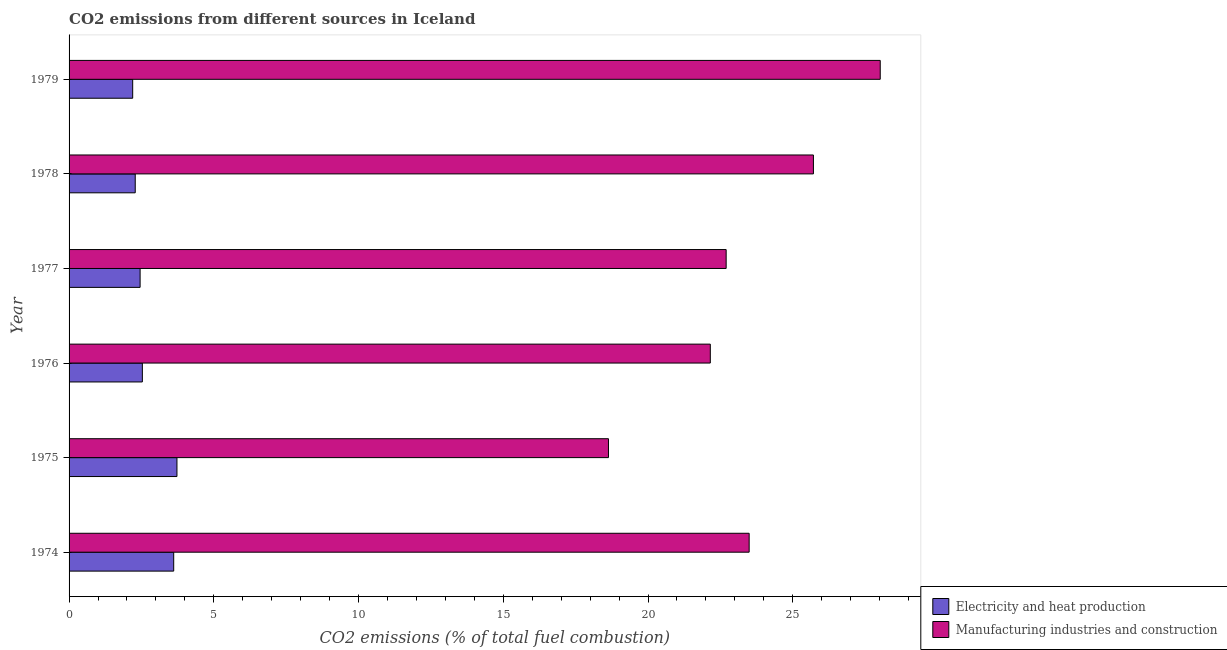How many different coloured bars are there?
Your answer should be compact. 2. How many groups of bars are there?
Make the answer very short. 6. Are the number of bars on each tick of the Y-axis equal?
Your answer should be very brief. Yes. How many bars are there on the 4th tick from the top?
Provide a short and direct response. 2. How many bars are there on the 5th tick from the bottom?
Give a very brief answer. 2. What is the label of the 2nd group of bars from the top?
Provide a succinct answer. 1978. What is the co2 emissions due to electricity and heat production in 1975?
Keep it short and to the point. 3.73. Across all years, what is the maximum co2 emissions due to electricity and heat production?
Provide a short and direct response. 3.73. Across all years, what is the minimum co2 emissions due to manufacturing industries?
Provide a short and direct response. 18.63. In which year was the co2 emissions due to electricity and heat production maximum?
Offer a very short reply. 1975. In which year was the co2 emissions due to manufacturing industries minimum?
Your response must be concise. 1975. What is the total co2 emissions due to manufacturing industries in the graph?
Offer a very short reply. 140.72. What is the difference between the co2 emissions due to manufacturing industries in 1974 and that in 1977?
Ensure brevity in your answer.  0.8. What is the difference between the co2 emissions due to electricity and heat production in 1975 and the co2 emissions due to manufacturing industries in 1974?
Keep it short and to the point. -19.77. What is the average co2 emissions due to manufacturing industries per year?
Your answer should be very brief. 23.45. In the year 1975, what is the difference between the co2 emissions due to electricity and heat production and co2 emissions due to manufacturing industries?
Provide a short and direct response. -14.91. What is the ratio of the co2 emissions due to electricity and heat production in 1976 to that in 1977?
Keep it short and to the point. 1.03. Is the difference between the co2 emissions due to electricity and heat production in 1976 and 1978 greater than the difference between the co2 emissions due to manufacturing industries in 1976 and 1978?
Ensure brevity in your answer.  Yes. What is the difference between the highest and the second highest co2 emissions due to manufacturing industries?
Give a very brief answer. 2.31. What is the difference between the highest and the lowest co2 emissions due to electricity and heat production?
Ensure brevity in your answer.  1.53. In how many years, is the co2 emissions due to electricity and heat production greater than the average co2 emissions due to electricity and heat production taken over all years?
Provide a succinct answer. 2. Is the sum of the co2 emissions due to electricity and heat production in 1974 and 1979 greater than the maximum co2 emissions due to manufacturing industries across all years?
Keep it short and to the point. No. What does the 1st bar from the top in 1977 represents?
Your response must be concise. Manufacturing industries and construction. What does the 2nd bar from the bottom in 1974 represents?
Give a very brief answer. Manufacturing industries and construction. What is the difference between two consecutive major ticks on the X-axis?
Your answer should be compact. 5. Are the values on the major ticks of X-axis written in scientific E-notation?
Your answer should be compact. No. Does the graph contain any zero values?
Your answer should be very brief. No. Where does the legend appear in the graph?
Provide a succinct answer. Bottom right. What is the title of the graph?
Provide a succinct answer. CO2 emissions from different sources in Iceland. What is the label or title of the X-axis?
Keep it short and to the point. CO2 emissions (% of total fuel combustion). What is the label or title of the Y-axis?
Your answer should be compact. Year. What is the CO2 emissions (% of total fuel combustion) in Electricity and heat production in 1974?
Your answer should be compact. 3.61. What is the CO2 emissions (% of total fuel combustion) of Manufacturing industries and construction in 1974?
Keep it short and to the point. 23.49. What is the CO2 emissions (% of total fuel combustion) in Electricity and heat production in 1975?
Your response must be concise. 3.73. What is the CO2 emissions (% of total fuel combustion) of Manufacturing industries and construction in 1975?
Offer a terse response. 18.63. What is the CO2 emissions (% of total fuel combustion) of Electricity and heat production in 1976?
Ensure brevity in your answer.  2.53. What is the CO2 emissions (% of total fuel combustion) of Manufacturing industries and construction in 1976?
Offer a very short reply. 22.15. What is the CO2 emissions (% of total fuel combustion) in Electricity and heat production in 1977?
Your answer should be very brief. 2.45. What is the CO2 emissions (% of total fuel combustion) of Manufacturing industries and construction in 1977?
Provide a succinct answer. 22.7. What is the CO2 emissions (% of total fuel combustion) of Electricity and heat production in 1978?
Offer a terse response. 2.29. What is the CO2 emissions (% of total fuel combustion) of Manufacturing industries and construction in 1978?
Provide a short and direct response. 25.71. What is the CO2 emissions (% of total fuel combustion) of Electricity and heat production in 1979?
Give a very brief answer. 2.2. What is the CO2 emissions (% of total fuel combustion) in Manufacturing industries and construction in 1979?
Provide a short and direct response. 28.02. Across all years, what is the maximum CO2 emissions (% of total fuel combustion) in Electricity and heat production?
Your response must be concise. 3.73. Across all years, what is the maximum CO2 emissions (% of total fuel combustion) of Manufacturing industries and construction?
Offer a very short reply. 28.02. Across all years, what is the minimum CO2 emissions (% of total fuel combustion) in Electricity and heat production?
Provide a short and direct response. 2.2. Across all years, what is the minimum CO2 emissions (% of total fuel combustion) in Manufacturing industries and construction?
Your answer should be compact. 18.63. What is the total CO2 emissions (% of total fuel combustion) of Electricity and heat production in the graph?
Provide a succinct answer. 16.81. What is the total CO2 emissions (% of total fuel combustion) in Manufacturing industries and construction in the graph?
Ensure brevity in your answer.  140.72. What is the difference between the CO2 emissions (% of total fuel combustion) in Electricity and heat production in 1974 and that in 1975?
Provide a short and direct response. -0.11. What is the difference between the CO2 emissions (% of total fuel combustion) of Manufacturing industries and construction in 1974 and that in 1975?
Ensure brevity in your answer.  4.86. What is the difference between the CO2 emissions (% of total fuel combustion) of Electricity and heat production in 1974 and that in 1976?
Ensure brevity in your answer.  1.08. What is the difference between the CO2 emissions (% of total fuel combustion) of Manufacturing industries and construction in 1974 and that in 1976?
Your answer should be compact. 1.34. What is the difference between the CO2 emissions (% of total fuel combustion) in Electricity and heat production in 1974 and that in 1977?
Provide a succinct answer. 1.16. What is the difference between the CO2 emissions (% of total fuel combustion) of Manufacturing industries and construction in 1974 and that in 1977?
Your answer should be compact. 0.79. What is the difference between the CO2 emissions (% of total fuel combustion) in Electricity and heat production in 1974 and that in 1978?
Give a very brief answer. 1.33. What is the difference between the CO2 emissions (% of total fuel combustion) of Manufacturing industries and construction in 1974 and that in 1978?
Your response must be concise. -2.22. What is the difference between the CO2 emissions (% of total fuel combustion) in Electricity and heat production in 1974 and that in 1979?
Offer a very short reply. 1.42. What is the difference between the CO2 emissions (% of total fuel combustion) of Manufacturing industries and construction in 1974 and that in 1979?
Give a very brief answer. -4.53. What is the difference between the CO2 emissions (% of total fuel combustion) of Electricity and heat production in 1975 and that in 1976?
Provide a short and direct response. 1.2. What is the difference between the CO2 emissions (% of total fuel combustion) of Manufacturing industries and construction in 1975 and that in 1976?
Your response must be concise. -3.52. What is the difference between the CO2 emissions (% of total fuel combustion) of Electricity and heat production in 1975 and that in 1977?
Offer a very short reply. 1.27. What is the difference between the CO2 emissions (% of total fuel combustion) in Manufacturing industries and construction in 1975 and that in 1977?
Offer a very short reply. -4.07. What is the difference between the CO2 emissions (% of total fuel combustion) of Electricity and heat production in 1975 and that in 1978?
Your response must be concise. 1.44. What is the difference between the CO2 emissions (% of total fuel combustion) of Manufacturing industries and construction in 1975 and that in 1978?
Give a very brief answer. -7.08. What is the difference between the CO2 emissions (% of total fuel combustion) of Electricity and heat production in 1975 and that in 1979?
Keep it short and to the point. 1.53. What is the difference between the CO2 emissions (% of total fuel combustion) of Manufacturing industries and construction in 1975 and that in 1979?
Provide a short and direct response. -9.39. What is the difference between the CO2 emissions (% of total fuel combustion) of Electricity and heat production in 1976 and that in 1977?
Keep it short and to the point. 0.08. What is the difference between the CO2 emissions (% of total fuel combustion) in Manufacturing industries and construction in 1976 and that in 1977?
Your response must be concise. -0.55. What is the difference between the CO2 emissions (% of total fuel combustion) in Electricity and heat production in 1976 and that in 1978?
Provide a succinct answer. 0.25. What is the difference between the CO2 emissions (% of total fuel combustion) of Manufacturing industries and construction in 1976 and that in 1978?
Make the answer very short. -3.56. What is the difference between the CO2 emissions (% of total fuel combustion) in Electricity and heat production in 1976 and that in 1979?
Provide a succinct answer. 0.33. What is the difference between the CO2 emissions (% of total fuel combustion) of Manufacturing industries and construction in 1976 and that in 1979?
Offer a very short reply. -5.87. What is the difference between the CO2 emissions (% of total fuel combustion) in Electricity and heat production in 1977 and that in 1978?
Provide a succinct answer. 0.17. What is the difference between the CO2 emissions (% of total fuel combustion) of Manufacturing industries and construction in 1977 and that in 1978?
Your response must be concise. -3.01. What is the difference between the CO2 emissions (% of total fuel combustion) of Electricity and heat production in 1977 and that in 1979?
Ensure brevity in your answer.  0.26. What is the difference between the CO2 emissions (% of total fuel combustion) of Manufacturing industries and construction in 1977 and that in 1979?
Provide a succinct answer. -5.32. What is the difference between the CO2 emissions (% of total fuel combustion) of Electricity and heat production in 1978 and that in 1979?
Keep it short and to the point. 0.09. What is the difference between the CO2 emissions (% of total fuel combustion) in Manufacturing industries and construction in 1978 and that in 1979?
Offer a very short reply. -2.31. What is the difference between the CO2 emissions (% of total fuel combustion) of Electricity and heat production in 1974 and the CO2 emissions (% of total fuel combustion) of Manufacturing industries and construction in 1975?
Provide a short and direct response. -15.02. What is the difference between the CO2 emissions (% of total fuel combustion) of Electricity and heat production in 1974 and the CO2 emissions (% of total fuel combustion) of Manufacturing industries and construction in 1976?
Offer a very short reply. -18.54. What is the difference between the CO2 emissions (% of total fuel combustion) in Electricity and heat production in 1974 and the CO2 emissions (% of total fuel combustion) in Manufacturing industries and construction in 1977?
Make the answer very short. -19.08. What is the difference between the CO2 emissions (% of total fuel combustion) in Electricity and heat production in 1974 and the CO2 emissions (% of total fuel combustion) in Manufacturing industries and construction in 1978?
Provide a short and direct response. -22.1. What is the difference between the CO2 emissions (% of total fuel combustion) in Electricity and heat production in 1974 and the CO2 emissions (% of total fuel combustion) in Manufacturing industries and construction in 1979?
Offer a terse response. -24.41. What is the difference between the CO2 emissions (% of total fuel combustion) of Electricity and heat production in 1975 and the CO2 emissions (% of total fuel combustion) of Manufacturing industries and construction in 1976?
Keep it short and to the point. -18.43. What is the difference between the CO2 emissions (% of total fuel combustion) in Electricity and heat production in 1975 and the CO2 emissions (% of total fuel combustion) in Manufacturing industries and construction in 1977?
Offer a terse response. -18.97. What is the difference between the CO2 emissions (% of total fuel combustion) in Electricity and heat production in 1975 and the CO2 emissions (% of total fuel combustion) in Manufacturing industries and construction in 1978?
Give a very brief answer. -21.99. What is the difference between the CO2 emissions (% of total fuel combustion) in Electricity and heat production in 1975 and the CO2 emissions (% of total fuel combustion) in Manufacturing industries and construction in 1979?
Your answer should be compact. -24.3. What is the difference between the CO2 emissions (% of total fuel combustion) in Electricity and heat production in 1976 and the CO2 emissions (% of total fuel combustion) in Manufacturing industries and construction in 1977?
Your response must be concise. -20.17. What is the difference between the CO2 emissions (% of total fuel combustion) in Electricity and heat production in 1976 and the CO2 emissions (% of total fuel combustion) in Manufacturing industries and construction in 1978?
Offer a very short reply. -23.18. What is the difference between the CO2 emissions (% of total fuel combustion) of Electricity and heat production in 1976 and the CO2 emissions (% of total fuel combustion) of Manufacturing industries and construction in 1979?
Provide a succinct answer. -25.49. What is the difference between the CO2 emissions (% of total fuel combustion) of Electricity and heat production in 1977 and the CO2 emissions (% of total fuel combustion) of Manufacturing industries and construction in 1978?
Offer a terse response. -23.26. What is the difference between the CO2 emissions (% of total fuel combustion) in Electricity and heat production in 1977 and the CO2 emissions (% of total fuel combustion) in Manufacturing industries and construction in 1979?
Ensure brevity in your answer.  -25.57. What is the difference between the CO2 emissions (% of total fuel combustion) in Electricity and heat production in 1978 and the CO2 emissions (% of total fuel combustion) in Manufacturing industries and construction in 1979?
Give a very brief answer. -25.74. What is the average CO2 emissions (% of total fuel combustion) of Electricity and heat production per year?
Keep it short and to the point. 2.8. What is the average CO2 emissions (% of total fuel combustion) of Manufacturing industries and construction per year?
Provide a short and direct response. 23.45. In the year 1974, what is the difference between the CO2 emissions (% of total fuel combustion) of Electricity and heat production and CO2 emissions (% of total fuel combustion) of Manufacturing industries and construction?
Ensure brevity in your answer.  -19.88. In the year 1975, what is the difference between the CO2 emissions (% of total fuel combustion) of Electricity and heat production and CO2 emissions (% of total fuel combustion) of Manufacturing industries and construction?
Offer a very short reply. -14.91. In the year 1976, what is the difference between the CO2 emissions (% of total fuel combustion) in Electricity and heat production and CO2 emissions (% of total fuel combustion) in Manufacturing industries and construction?
Keep it short and to the point. -19.62. In the year 1977, what is the difference between the CO2 emissions (% of total fuel combustion) in Electricity and heat production and CO2 emissions (% of total fuel combustion) in Manufacturing industries and construction?
Your answer should be very brief. -20.25. In the year 1978, what is the difference between the CO2 emissions (% of total fuel combustion) of Electricity and heat production and CO2 emissions (% of total fuel combustion) of Manufacturing industries and construction?
Offer a terse response. -23.43. In the year 1979, what is the difference between the CO2 emissions (% of total fuel combustion) in Electricity and heat production and CO2 emissions (% of total fuel combustion) in Manufacturing industries and construction?
Make the answer very short. -25.82. What is the ratio of the CO2 emissions (% of total fuel combustion) of Electricity and heat production in 1974 to that in 1975?
Make the answer very short. 0.97. What is the ratio of the CO2 emissions (% of total fuel combustion) in Manufacturing industries and construction in 1974 to that in 1975?
Give a very brief answer. 1.26. What is the ratio of the CO2 emissions (% of total fuel combustion) of Electricity and heat production in 1974 to that in 1976?
Keep it short and to the point. 1.43. What is the ratio of the CO2 emissions (% of total fuel combustion) of Manufacturing industries and construction in 1974 to that in 1976?
Your answer should be very brief. 1.06. What is the ratio of the CO2 emissions (% of total fuel combustion) in Electricity and heat production in 1974 to that in 1977?
Make the answer very short. 1.47. What is the ratio of the CO2 emissions (% of total fuel combustion) of Manufacturing industries and construction in 1974 to that in 1977?
Your answer should be compact. 1.03. What is the ratio of the CO2 emissions (% of total fuel combustion) of Electricity and heat production in 1974 to that in 1978?
Your answer should be very brief. 1.58. What is the ratio of the CO2 emissions (% of total fuel combustion) of Manufacturing industries and construction in 1974 to that in 1978?
Ensure brevity in your answer.  0.91. What is the ratio of the CO2 emissions (% of total fuel combustion) of Electricity and heat production in 1974 to that in 1979?
Offer a terse response. 1.64. What is the ratio of the CO2 emissions (% of total fuel combustion) of Manufacturing industries and construction in 1974 to that in 1979?
Your response must be concise. 0.84. What is the ratio of the CO2 emissions (% of total fuel combustion) in Electricity and heat production in 1975 to that in 1976?
Your answer should be very brief. 1.47. What is the ratio of the CO2 emissions (% of total fuel combustion) of Manufacturing industries and construction in 1975 to that in 1976?
Provide a short and direct response. 0.84. What is the ratio of the CO2 emissions (% of total fuel combustion) in Electricity and heat production in 1975 to that in 1977?
Keep it short and to the point. 1.52. What is the ratio of the CO2 emissions (% of total fuel combustion) in Manufacturing industries and construction in 1975 to that in 1977?
Give a very brief answer. 0.82. What is the ratio of the CO2 emissions (% of total fuel combustion) in Electricity and heat production in 1975 to that in 1978?
Provide a succinct answer. 1.63. What is the ratio of the CO2 emissions (% of total fuel combustion) of Manufacturing industries and construction in 1975 to that in 1978?
Your response must be concise. 0.72. What is the ratio of the CO2 emissions (% of total fuel combustion) of Electricity and heat production in 1975 to that in 1979?
Provide a succinct answer. 1.7. What is the ratio of the CO2 emissions (% of total fuel combustion) of Manufacturing industries and construction in 1975 to that in 1979?
Offer a very short reply. 0.67. What is the ratio of the CO2 emissions (% of total fuel combustion) of Electricity and heat production in 1976 to that in 1977?
Your answer should be very brief. 1.03. What is the ratio of the CO2 emissions (% of total fuel combustion) in Manufacturing industries and construction in 1976 to that in 1977?
Offer a very short reply. 0.98. What is the ratio of the CO2 emissions (% of total fuel combustion) of Electricity and heat production in 1976 to that in 1978?
Your response must be concise. 1.11. What is the ratio of the CO2 emissions (% of total fuel combustion) of Manufacturing industries and construction in 1976 to that in 1978?
Give a very brief answer. 0.86. What is the ratio of the CO2 emissions (% of total fuel combustion) in Electricity and heat production in 1976 to that in 1979?
Offer a very short reply. 1.15. What is the ratio of the CO2 emissions (% of total fuel combustion) in Manufacturing industries and construction in 1976 to that in 1979?
Offer a very short reply. 0.79. What is the ratio of the CO2 emissions (% of total fuel combustion) in Electricity and heat production in 1977 to that in 1978?
Give a very brief answer. 1.07. What is the ratio of the CO2 emissions (% of total fuel combustion) in Manufacturing industries and construction in 1977 to that in 1978?
Make the answer very short. 0.88. What is the ratio of the CO2 emissions (% of total fuel combustion) in Electricity and heat production in 1977 to that in 1979?
Your answer should be compact. 1.12. What is the ratio of the CO2 emissions (% of total fuel combustion) of Manufacturing industries and construction in 1977 to that in 1979?
Ensure brevity in your answer.  0.81. What is the ratio of the CO2 emissions (% of total fuel combustion) of Electricity and heat production in 1978 to that in 1979?
Ensure brevity in your answer.  1.04. What is the ratio of the CO2 emissions (% of total fuel combustion) in Manufacturing industries and construction in 1978 to that in 1979?
Keep it short and to the point. 0.92. What is the difference between the highest and the second highest CO2 emissions (% of total fuel combustion) of Electricity and heat production?
Make the answer very short. 0.11. What is the difference between the highest and the second highest CO2 emissions (% of total fuel combustion) of Manufacturing industries and construction?
Ensure brevity in your answer.  2.31. What is the difference between the highest and the lowest CO2 emissions (% of total fuel combustion) of Electricity and heat production?
Make the answer very short. 1.53. What is the difference between the highest and the lowest CO2 emissions (% of total fuel combustion) of Manufacturing industries and construction?
Ensure brevity in your answer.  9.39. 